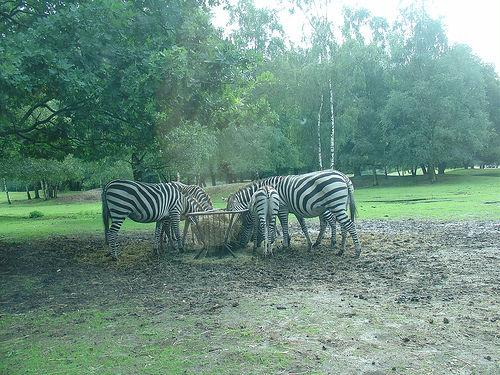These animals are mascots for what brand of gum? fruit stripe 